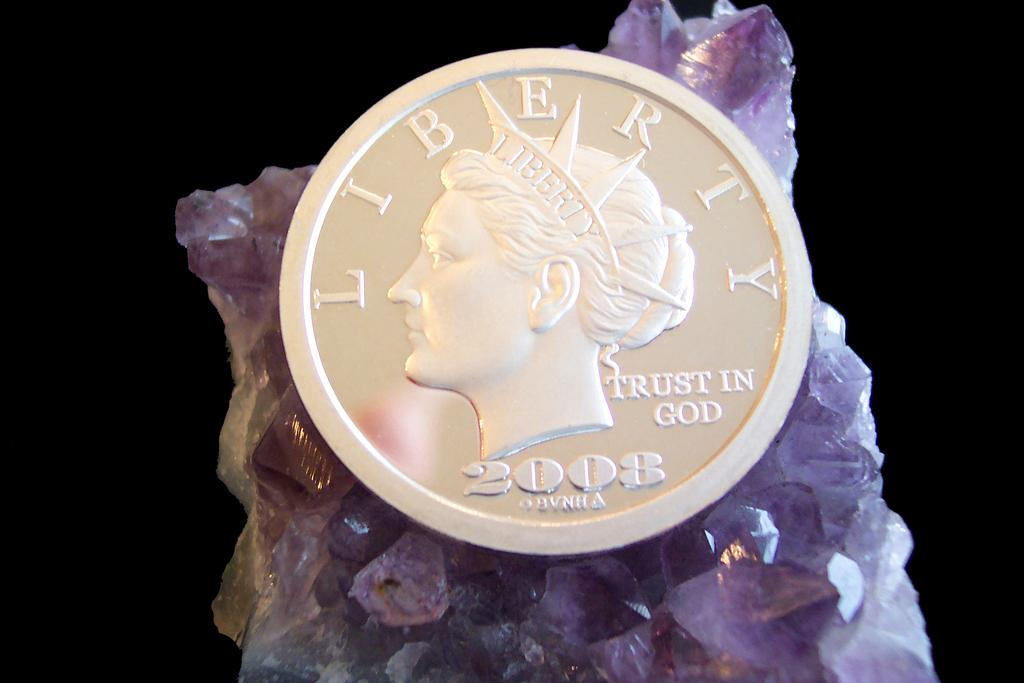What object is placed on the surface in the image? There is a coin on the surface. What can be seen on the coin? The coin has a woman's face on it. How would you describe the overall appearance of the image? The background is dark. Where is the most comfortable spot to sit and eat lunch in the image? There is no reference to a lunchroom or a comfortable spot to sit in the image; it only features a coin with a woman's face on it and a dark background. Can you see the ocean in the image? No, there is no ocean visible in the image. 